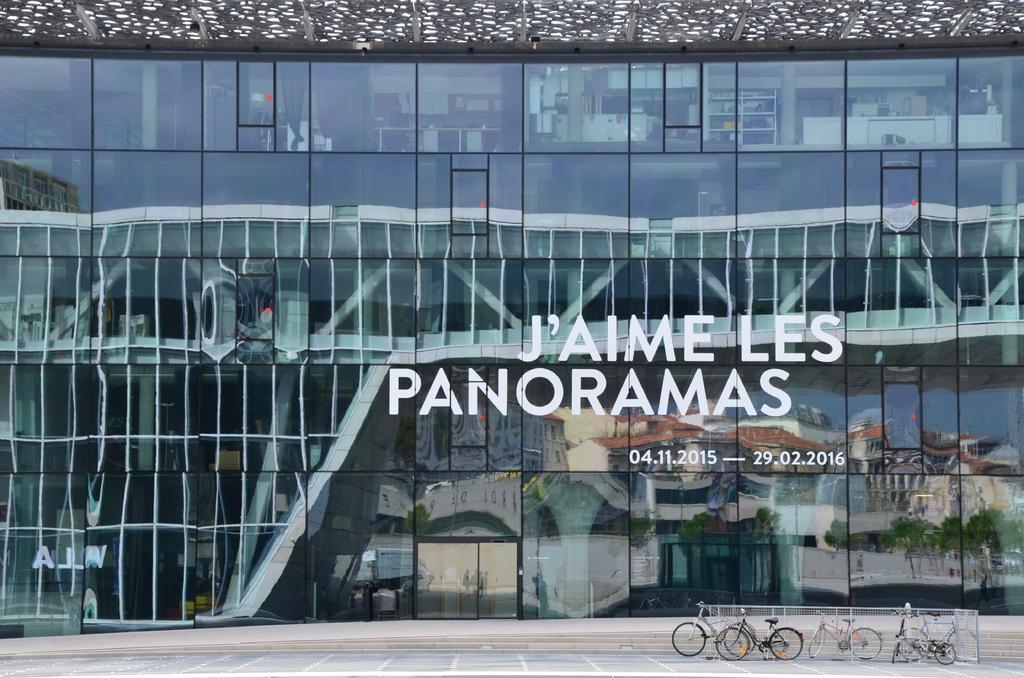Please provide a concise description of this image. In the image I can see a glass building and also I can see some bicycles on the ground. 